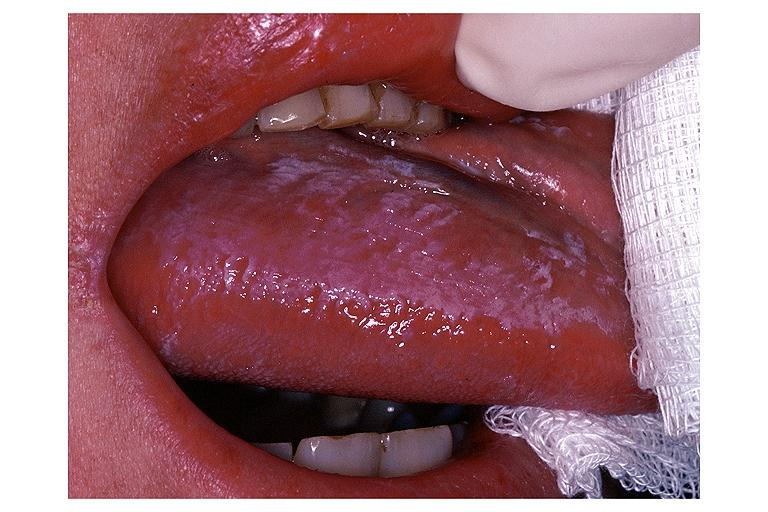does this image show oral hairy leukoplakia?
Answer the question using a single word or phrase. Yes 